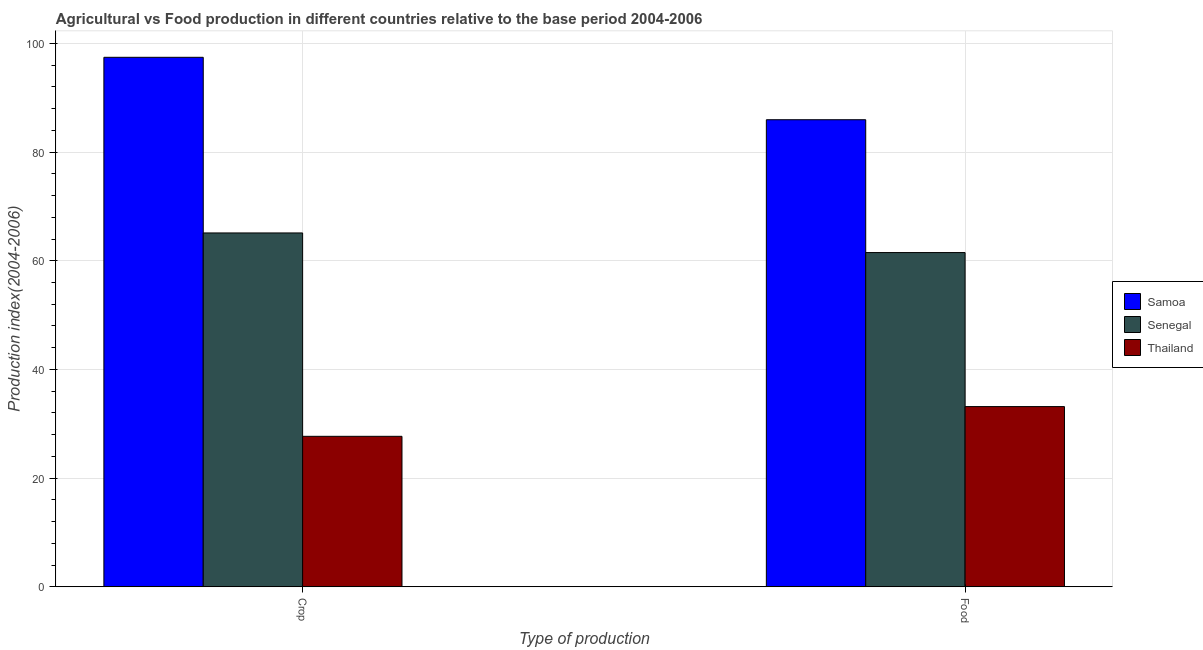Are the number of bars per tick equal to the number of legend labels?
Your response must be concise. Yes. What is the label of the 2nd group of bars from the left?
Your response must be concise. Food. What is the crop production index in Thailand?
Offer a terse response. 27.69. Across all countries, what is the maximum food production index?
Offer a terse response. 85.96. Across all countries, what is the minimum food production index?
Make the answer very short. 33.16. In which country was the food production index maximum?
Give a very brief answer. Samoa. In which country was the food production index minimum?
Ensure brevity in your answer.  Thailand. What is the total crop production index in the graph?
Give a very brief answer. 190.26. What is the difference between the food production index in Samoa and that in Senegal?
Your response must be concise. 24.45. What is the difference between the food production index in Thailand and the crop production index in Senegal?
Give a very brief answer. -31.96. What is the average food production index per country?
Keep it short and to the point. 60.21. What is the difference between the food production index and crop production index in Senegal?
Your response must be concise. -3.61. What is the ratio of the crop production index in Senegal to that in Samoa?
Your response must be concise. 0.67. What does the 2nd bar from the left in Food represents?
Provide a short and direct response. Senegal. What does the 1st bar from the right in Crop represents?
Provide a succinct answer. Thailand. How many bars are there?
Give a very brief answer. 6. Are all the bars in the graph horizontal?
Your response must be concise. No. How many countries are there in the graph?
Make the answer very short. 3. Are the values on the major ticks of Y-axis written in scientific E-notation?
Your response must be concise. No. Does the graph contain any zero values?
Offer a very short reply. No. Does the graph contain grids?
Your answer should be compact. Yes. Where does the legend appear in the graph?
Your response must be concise. Center right. How are the legend labels stacked?
Ensure brevity in your answer.  Vertical. What is the title of the graph?
Make the answer very short. Agricultural vs Food production in different countries relative to the base period 2004-2006. Does "Trinidad and Tobago" appear as one of the legend labels in the graph?
Provide a short and direct response. No. What is the label or title of the X-axis?
Your answer should be compact. Type of production. What is the label or title of the Y-axis?
Ensure brevity in your answer.  Production index(2004-2006). What is the Production index(2004-2006) of Samoa in Crop?
Offer a terse response. 97.45. What is the Production index(2004-2006) in Senegal in Crop?
Ensure brevity in your answer.  65.12. What is the Production index(2004-2006) in Thailand in Crop?
Ensure brevity in your answer.  27.69. What is the Production index(2004-2006) of Samoa in Food?
Your response must be concise. 85.96. What is the Production index(2004-2006) of Senegal in Food?
Offer a terse response. 61.51. What is the Production index(2004-2006) in Thailand in Food?
Ensure brevity in your answer.  33.16. Across all Type of production, what is the maximum Production index(2004-2006) of Samoa?
Ensure brevity in your answer.  97.45. Across all Type of production, what is the maximum Production index(2004-2006) of Senegal?
Provide a succinct answer. 65.12. Across all Type of production, what is the maximum Production index(2004-2006) of Thailand?
Ensure brevity in your answer.  33.16. Across all Type of production, what is the minimum Production index(2004-2006) of Samoa?
Provide a succinct answer. 85.96. Across all Type of production, what is the minimum Production index(2004-2006) in Senegal?
Ensure brevity in your answer.  61.51. Across all Type of production, what is the minimum Production index(2004-2006) in Thailand?
Offer a terse response. 27.69. What is the total Production index(2004-2006) of Samoa in the graph?
Offer a terse response. 183.41. What is the total Production index(2004-2006) of Senegal in the graph?
Provide a short and direct response. 126.63. What is the total Production index(2004-2006) in Thailand in the graph?
Give a very brief answer. 60.85. What is the difference between the Production index(2004-2006) in Samoa in Crop and that in Food?
Ensure brevity in your answer.  11.49. What is the difference between the Production index(2004-2006) of Senegal in Crop and that in Food?
Your answer should be compact. 3.61. What is the difference between the Production index(2004-2006) in Thailand in Crop and that in Food?
Your answer should be compact. -5.47. What is the difference between the Production index(2004-2006) in Samoa in Crop and the Production index(2004-2006) in Senegal in Food?
Give a very brief answer. 35.94. What is the difference between the Production index(2004-2006) in Samoa in Crop and the Production index(2004-2006) in Thailand in Food?
Ensure brevity in your answer.  64.29. What is the difference between the Production index(2004-2006) in Senegal in Crop and the Production index(2004-2006) in Thailand in Food?
Provide a succinct answer. 31.96. What is the average Production index(2004-2006) in Samoa per Type of production?
Keep it short and to the point. 91.7. What is the average Production index(2004-2006) in Senegal per Type of production?
Give a very brief answer. 63.31. What is the average Production index(2004-2006) in Thailand per Type of production?
Provide a succinct answer. 30.43. What is the difference between the Production index(2004-2006) of Samoa and Production index(2004-2006) of Senegal in Crop?
Keep it short and to the point. 32.33. What is the difference between the Production index(2004-2006) of Samoa and Production index(2004-2006) of Thailand in Crop?
Offer a very short reply. 69.76. What is the difference between the Production index(2004-2006) of Senegal and Production index(2004-2006) of Thailand in Crop?
Your answer should be very brief. 37.43. What is the difference between the Production index(2004-2006) of Samoa and Production index(2004-2006) of Senegal in Food?
Give a very brief answer. 24.45. What is the difference between the Production index(2004-2006) of Samoa and Production index(2004-2006) of Thailand in Food?
Ensure brevity in your answer.  52.8. What is the difference between the Production index(2004-2006) in Senegal and Production index(2004-2006) in Thailand in Food?
Provide a short and direct response. 28.35. What is the ratio of the Production index(2004-2006) of Samoa in Crop to that in Food?
Offer a terse response. 1.13. What is the ratio of the Production index(2004-2006) of Senegal in Crop to that in Food?
Ensure brevity in your answer.  1.06. What is the ratio of the Production index(2004-2006) in Thailand in Crop to that in Food?
Your answer should be compact. 0.83. What is the difference between the highest and the second highest Production index(2004-2006) in Samoa?
Your answer should be compact. 11.49. What is the difference between the highest and the second highest Production index(2004-2006) of Senegal?
Ensure brevity in your answer.  3.61. What is the difference between the highest and the second highest Production index(2004-2006) in Thailand?
Your answer should be compact. 5.47. What is the difference between the highest and the lowest Production index(2004-2006) of Samoa?
Provide a short and direct response. 11.49. What is the difference between the highest and the lowest Production index(2004-2006) of Senegal?
Provide a short and direct response. 3.61. What is the difference between the highest and the lowest Production index(2004-2006) of Thailand?
Your response must be concise. 5.47. 